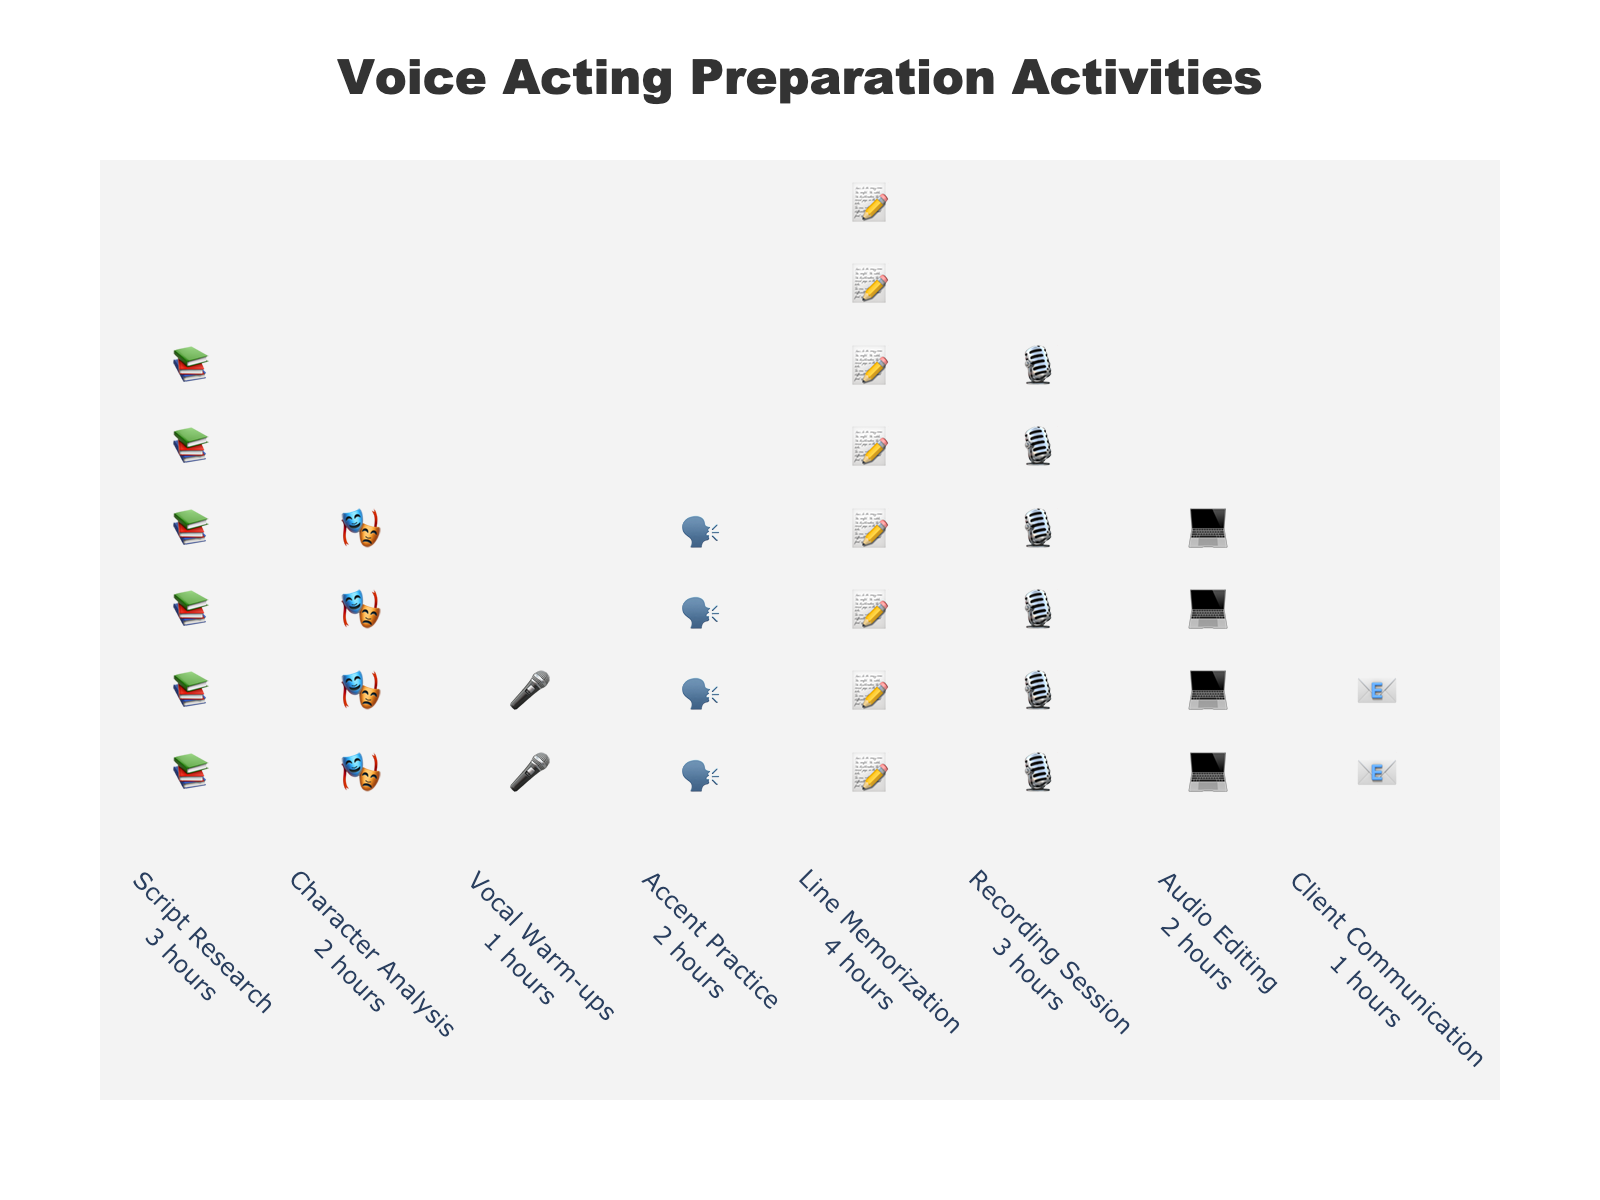What's the title of the plot? The title is usually located at the top of the plot. By reading it, we can understand what the plot is about.
Answer: Voice Acting Preparation Activities How many hours are spent on script research? Script research is represented at one of the x-axis annotations. By looking at the corresponding icons or annotation, we can determine the hours.
Answer: 3 hours Which activity has the highest number of hours? By scanning the activities and their corresponding number of icons, the activity with the most icons (or annotation with the highest value) indicates the maximum hours.
Answer: Line Memorization What's the total number of hours spent on accent practice and character analysis combined? Find the hours for accent practice (2 hours) and character analysis (2 hours) and sum them up: 2 + 2 = 4 hours
Answer: 4 hours Which activities have the same number of hours? Look for activities that have the same number of icons or the same hour annotations.
Answer: Character Analysis and Accent Practice, each with 2 hours How many activities have 2 hours each? Count the number of activities that have annotations or icons that indicate 2 hours.
Answer: 3 activities How many icons are used for vocal warm-ups? Multiply the hours for vocal warm-ups by 2 (since the number of icons = 2 * hours). Vocal warm-ups have 1 hour, thus 1*2 = 2 icons.
Answer: 2 icons Which has more hours: recording session or audio editing? Compare the hours for recording session (3 hours) and audio editing (2 hours).
Answer: Recording session How many total hours are spent on all activities? Sum up the hours for all activities: 3 + 2 + 1 + 2 + 4 + 3 + 2 + 1 = 18 hours
Answer: 18 hours 